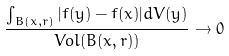<formula> <loc_0><loc_0><loc_500><loc_500>\frac { \int _ { B ( x , r ) } | f ( y ) - f ( x ) | d V ( y ) } { V o l ( B ( x , r ) ) } \rightarrow 0</formula> 